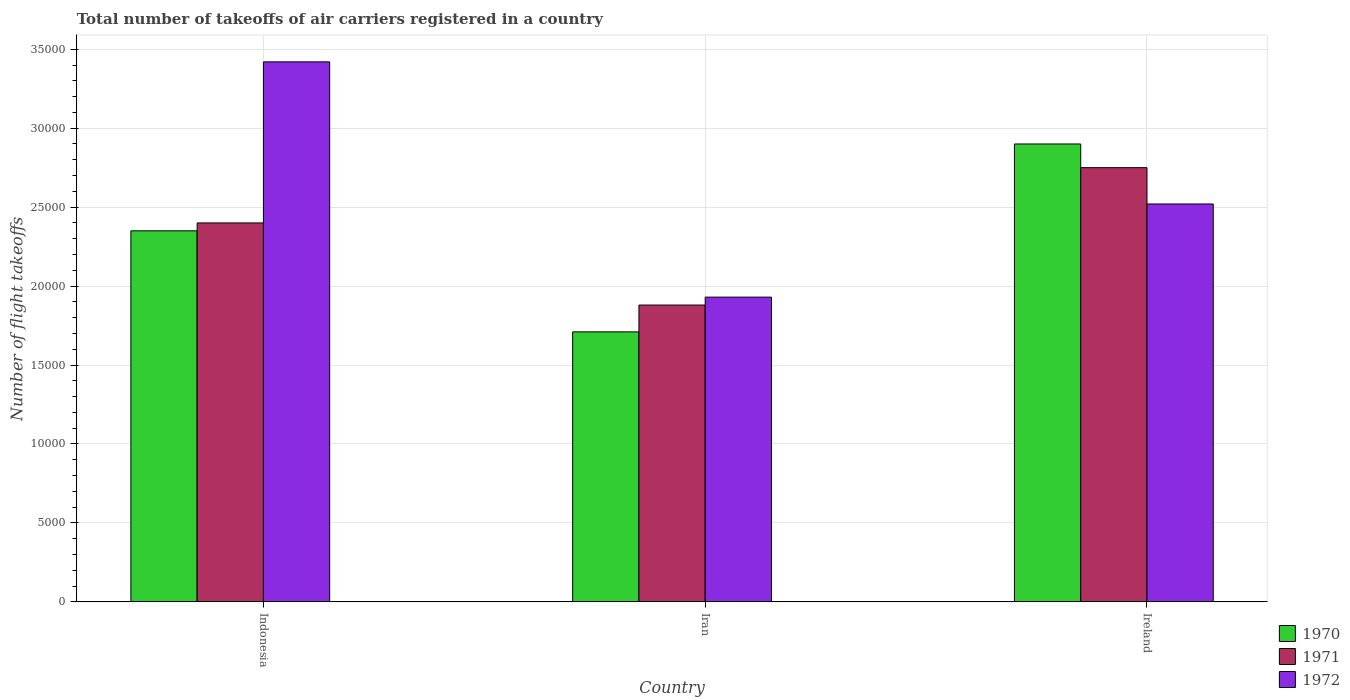Are the number of bars per tick equal to the number of legend labels?
Provide a succinct answer. Yes. How many bars are there on the 2nd tick from the left?
Offer a terse response. 3. How many bars are there on the 1st tick from the right?
Your answer should be compact. 3. In how many cases, is the number of bars for a given country not equal to the number of legend labels?
Your answer should be very brief. 0. What is the total number of flight takeoffs in 1972 in Ireland?
Give a very brief answer. 2.52e+04. Across all countries, what is the maximum total number of flight takeoffs in 1970?
Provide a succinct answer. 2.90e+04. Across all countries, what is the minimum total number of flight takeoffs in 1971?
Offer a terse response. 1.88e+04. In which country was the total number of flight takeoffs in 1970 maximum?
Your answer should be compact. Ireland. In which country was the total number of flight takeoffs in 1970 minimum?
Give a very brief answer. Iran. What is the total total number of flight takeoffs in 1971 in the graph?
Keep it short and to the point. 7.03e+04. What is the difference between the total number of flight takeoffs in 1972 in Indonesia and that in Ireland?
Your answer should be very brief. 9000. What is the difference between the total number of flight takeoffs in 1972 in Indonesia and the total number of flight takeoffs in 1970 in Ireland?
Your answer should be compact. 5200. What is the average total number of flight takeoffs in 1972 per country?
Make the answer very short. 2.62e+04. What is the difference between the total number of flight takeoffs of/in 1970 and total number of flight takeoffs of/in 1971 in Indonesia?
Offer a terse response. -500. In how many countries, is the total number of flight takeoffs in 1971 greater than 6000?
Your response must be concise. 3. What is the ratio of the total number of flight takeoffs in 1970 in Indonesia to that in Ireland?
Offer a very short reply. 0.81. Is the total number of flight takeoffs in 1970 in Indonesia less than that in Ireland?
Make the answer very short. Yes. Is the difference between the total number of flight takeoffs in 1970 in Iran and Ireland greater than the difference between the total number of flight takeoffs in 1971 in Iran and Ireland?
Offer a very short reply. No. What is the difference between the highest and the second highest total number of flight takeoffs in 1971?
Give a very brief answer. -3500. What is the difference between the highest and the lowest total number of flight takeoffs in 1971?
Your answer should be very brief. 8700. In how many countries, is the total number of flight takeoffs in 1971 greater than the average total number of flight takeoffs in 1971 taken over all countries?
Your answer should be very brief. 2. Is the sum of the total number of flight takeoffs in 1971 in Indonesia and Ireland greater than the maximum total number of flight takeoffs in 1970 across all countries?
Give a very brief answer. Yes. What does the 2nd bar from the right in Iran represents?
Ensure brevity in your answer.  1971. Are all the bars in the graph horizontal?
Make the answer very short. No. How many countries are there in the graph?
Keep it short and to the point. 3. Are the values on the major ticks of Y-axis written in scientific E-notation?
Make the answer very short. No. Does the graph contain grids?
Ensure brevity in your answer.  Yes. How many legend labels are there?
Your response must be concise. 3. How are the legend labels stacked?
Offer a terse response. Vertical. What is the title of the graph?
Keep it short and to the point. Total number of takeoffs of air carriers registered in a country. What is the label or title of the X-axis?
Keep it short and to the point. Country. What is the label or title of the Y-axis?
Ensure brevity in your answer.  Number of flight takeoffs. What is the Number of flight takeoffs of 1970 in Indonesia?
Offer a terse response. 2.35e+04. What is the Number of flight takeoffs in 1971 in Indonesia?
Offer a terse response. 2.40e+04. What is the Number of flight takeoffs of 1972 in Indonesia?
Offer a terse response. 3.42e+04. What is the Number of flight takeoffs of 1970 in Iran?
Make the answer very short. 1.71e+04. What is the Number of flight takeoffs in 1971 in Iran?
Give a very brief answer. 1.88e+04. What is the Number of flight takeoffs in 1972 in Iran?
Offer a very short reply. 1.93e+04. What is the Number of flight takeoffs in 1970 in Ireland?
Keep it short and to the point. 2.90e+04. What is the Number of flight takeoffs of 1971 in Ireland?
Your answer should be very brief. 2.75e+04. What is the Number of flight takeoffs of 1972 in Ireland?
Offer a terse response. 2.52e+04. Across all countries, what is the maximum Number of flight takeoffs of 1970?
Offer a very short reply. 2.90e+04. Across all countries, what is the maximum Number of flight takeoffs in 1971?
Your answer should be very brief. 2.75e+04. Across all countries, what is the maximum Number of flight takeoffs of 1972?
Provide a succinct answer. 3.42e+04. Across all countries, what is the minimum Number of flight takeoffs of 1970?
Keep it short and to the point. 1.71e+04. Across all countries, what is the minimum Number of flight takeoffs in 1971?
Give a very brief answer. 1.88e+04. Across all countries, what is the minimum Number of flight takeoffs of 1972?
Provide a short and direct response. 1.93e+04. What is the total Number of flight takeoffs of 1970 in the graph?
Offer a very short reply. 6.96e+04. What is the total Number of flight takeoffs in 1971 in the graph?
Ensure brevity in your answer.  7.03e+04. What is the total Number of flight takeoffs of 1972 in the graph?
Ensure brevity in your answer.  7.87e+04. What is the difference between the Number of flight takeoffs in 1970 in Indonesia and that in Iran?
Provide a succinct answer. 6400. What is the difference between the Number of flight takeoffs of 1971 in Indonesia and that in Iran?
Ensure brevity in your answer.  5200. What is the difference between the Number of flight takeoffs in 1972 in Indonesia and that in Iran?
Provide a succinct answer. 1.49e+04. What is the difference between the Number of flight takeoffs in 1970 in Indonesia and that in Ireland?
Offer a very short reply. -5500. What is the difference between the Number of flight takeoffs of 1971 in Indonesia and that in Ireland?
Provide a succinct answer. -3500. What is the difference between the Number of flight takeoffs of 1972 in Indonesia and that in Ireland?
Offer a very short reply. 9000. What is the difference between the Number of flight takeoffs of 1970 in Iran and that in Ireland?
Your answer should be very brief. -1.19e+04. What is the difference between the Number of flight takeoffs in 1971 in Iran and that in Ireland?
Provide a short and direct response. -8700. What is the difference between the Number of flight takeoffs in 1972 in Iran and that in Ireland?
Your answer should be very brief. -5900. What is the difference between the Number of flight takeoffs of 1970 in Indonesia and the Number of flight takeoffs of 1971 in Iran?
Offer a very short reply. 4700. What is the difference between the Number of flight takeoffs of 1970 in Indonesia and the Number of flight takeoffs of 1972 in Iran?
Give a very brief answer. 4200. What is the difference between the Number of flight takeoffs in 1971 in Indonesia and the Number of flight takeoffs in 1972 in Iran?
Offer a terse response. 4700. What is the difference between the Number of flight takeoffs in 1970 in Indonesia and the Number of flight takeoffs in 1971 in Ireland?
Provide a succinct answer. -4000. What is the difference between the Number of flight takeoffs of 1970 in Indonesia and the Number of flight takeoffs of 1972 in Ireland?
Offer a terse response. -1700. What is the difference between the Number of flight takeoffs in 1971 in Indonesia and the Number of flight takeoffs in 1972 in Ireland?
Keep it short and to the point. -1200. What is the difference between the Number of flight takeoffs of 1970 in Iran and the Number of flight takeoffs of 1971 in Ireland?
Offer a terse response. -1.04e+04. What is the difference between the Number of flight takeoffs in 1970 in Iran and the Number of flight takeoffs in 1972 in Ireland?
Give a very brief answer. -8100. What is the difference between the Number of flight takeoffs of 1971 in Iran and the Number of flight takeoffs of 1972 in Ireland?
Keep it short and to the point. -6400. What is the average Number of flight takeoffs in 1970 per country?
Offer a very short reply. 2.32e+04. What is the average Number of flight takeoffs in 1971 per country?
Offer a very short reply. 2.34e+04. What is the average Number of flight takeoffs of 1972 per country?
Provide a succinct answer. 2.62e+04. What is the difference between the Number of flight takeoffs of 1970 and Number of flight takeoffs of 1971 in Indonesia?
Ensure brevity in your answer.  -500. What is the difference between the Number of flight takeoffs of 1970 and Number of flight takeoffs of 1972 in Indonesia?
Make the answer very short. -1.07e+04. What is the difference between the Number of flight takeoffs of 1971 and Number of flight takeoffs of 1972 in Indonesia?
Offer a terse response. -1.02e+04. What is the difference between the Number of flight takeoffs of 1970 and Number of flight takeoffs of 1971 in Iran?
Keep it short and to the point. -1700. What is the difference between the Number of flight takeoffs in 1970 and Number of flight takeoffs in 1972 in Iran?
Your answer should be very brief. -2200. What is the difference between the Number of flight takeoffs in 1971 and Number of flight takeoffs in 1972 in Iran?
Give a very brief answer. -500. What is the difference between the Number of flight takeoffs in 1970 and Number of flight takeoffs in 1971 in Ireland?
Provide a short and direct response. 1500. What is the difference between the Number of flight takeoffs in 1970 and Number of flight takeoffs in 1972 in Ireland?
Ensure brevity in your answer.  3800. What is the difference between the Number of flight takeoffs in 1971 and Number of flight takeoffs in 1972 in Ireland?
Offer a terse response. 2300. What is the ratio of the Number of flight takeoffs of 1970 in Indonesia to that in Iran?
Ensure brevity in your answer.  1.37. What is the ratio of the Number of flight takeoffs of 1971 in Indonesia to that in Iran?
Keep it short and to the point. 1.28. What is the ratio of the Number of flight takeoffs in 1972 in Indonesia to that in Iran?
Ensure brevity in your answer.  1.77. What is the ratio of the Number of flight takeoffs in 1970 in Indonesia to that in Ireland?
Offer a terse response. 0.81. What is the ratio of the Number of flight takeoffs of 1971 in Indonesia to that in Ireland?
Offer a terse response. 0.87. What is the ratio of the Number of flight takeoffs in 1972 in Indonesia to that in Ireland?
Make the answer very short. 1.36. What is the ratio of the Number of flight takeoffs of 1970 in Iran to that in Ireland?
Provide a short and direct response. 0.59. What is the ratio of the Number of flight takeoffs in 1971 in Iran to that in Ireland?
Your answer should be compact. 0.68. What is the ratio of the Number of flight takeoffs in 1972 in Iran to that in Ireland?
Your answer should be compact. 0.77. What is the difference between the highest and the second highest Number of flight takeoffs of 1970?
Provide a short and direct response. 5500. What is the difference between the highest and the second highest Number of flight takeoffs of 1971?
Make the answer very short. 3500. What is the difference between the highest and the second highest Number of flight takeoffs in 1972?
Give a very brief answer. 9000. What is the difference between the highest and the lowest Number of flight takeoffs of 1970?
Your answer should be very brief. 1.19e+04. What is the difference between the highest and the lowest Number of flight takeoffs in 1971?
Offer a very short reply. 8700. What is the difference between the highest and the lowest Number of flight takeoffs in 1972?
Give a very brief answer. 1.49e+04. 